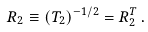<formula> <loc_0><loc_0><loc_500><loc_500>R _ { 2 } \equiv \left ( T _ { 2 } \right ) ^ { - 1 / 2 } = R _ { 2 } ^ { T } \, .</formula> 